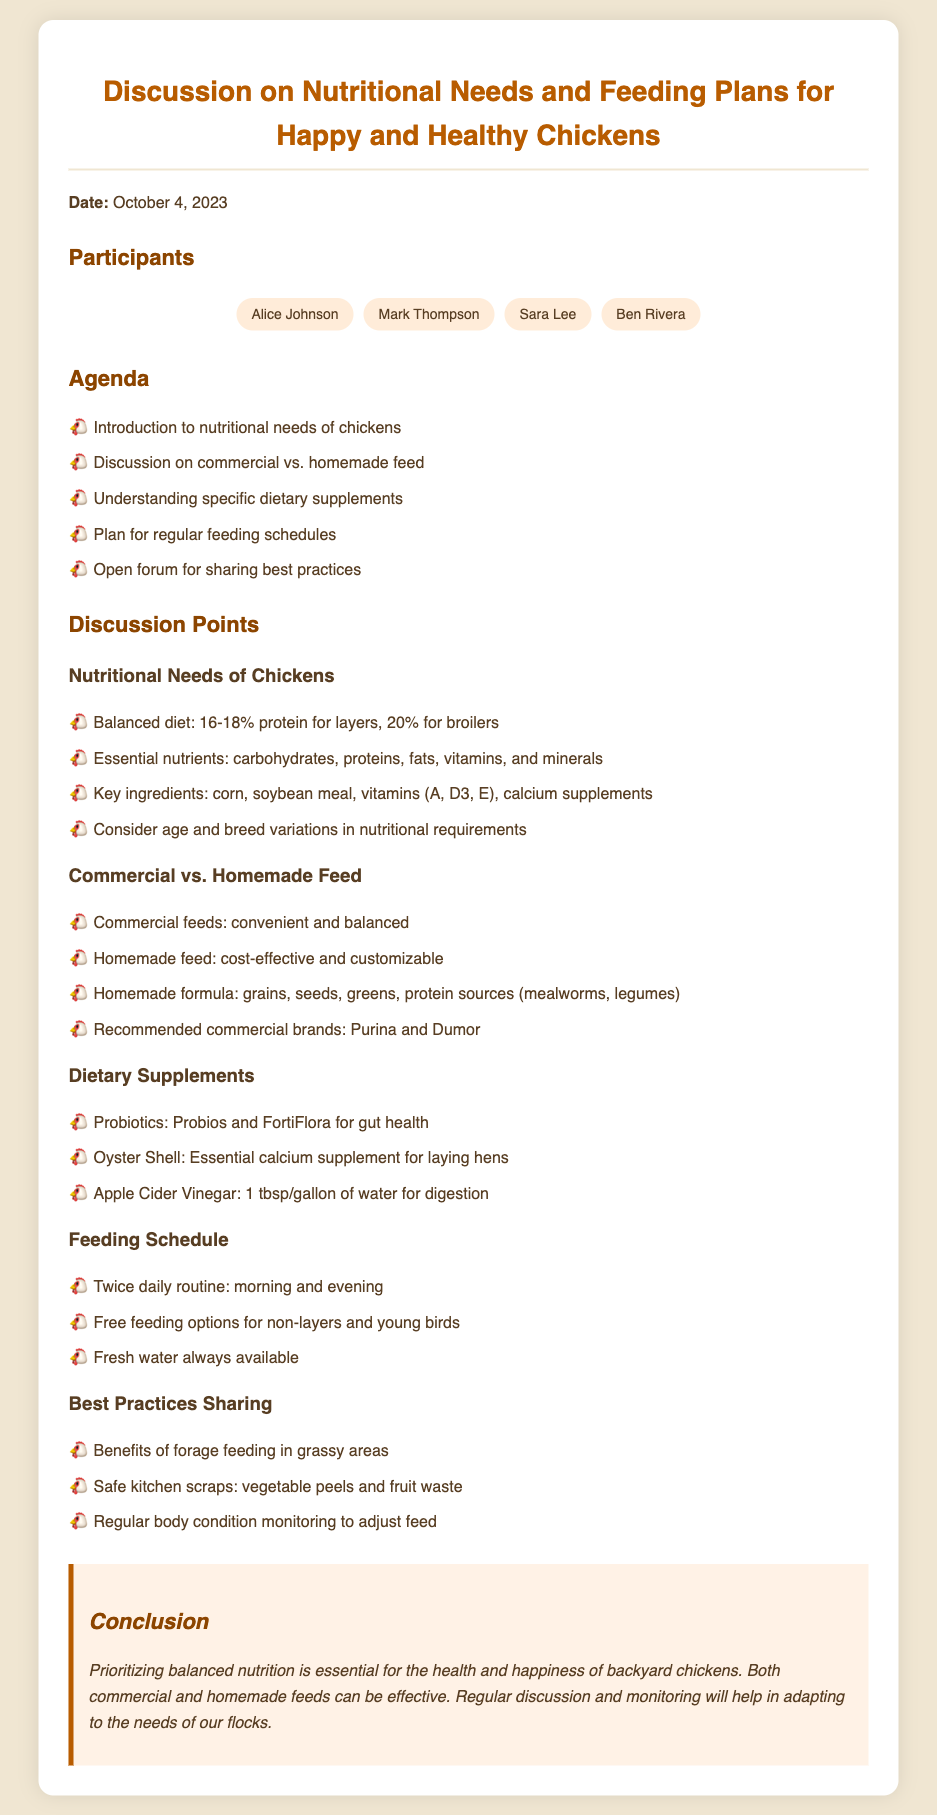What is the date of the meeting? The document states that the meeting took place on October 4, 2023.
Answer: October 4, 2023 Who is one of the participants? The document lists participants, including Alice Johnson.
Answer: Alice Johnson What percentage of protein is recommended for layers? The recommended protein percentage for layers, as mentioned in the document, is between 16-18%.
Answer: 16-18% What is a key ingredient for chicken feed? The document points out that corn is a key ingredient in chicken feed.
Answer: Corn What is one benefit of homemade feed mentioned? The document states that homemade feed is cost-effective, which is one of its benefits.
Answer: Cost-effective How often should chickens be fed according to the schedule? The feeding schedule in the document recommends feeding chickens twice daily.
Answer: Twice daily What dietary supplement is essential for laying hens? The essential dietary supplement for laying hens mentioned is oyster shell.
Answer: Oyster Shell Which commercial feed brands are recommended in the document? The document specifies Purina and Dumor as recommended commercial brands.
Answer: Purina and Dumor What is one safe kitchen scrap for chickens? The document lists vegetable peels as a safe kitchen scrap for chickens.
Answer: Vegetable peels 